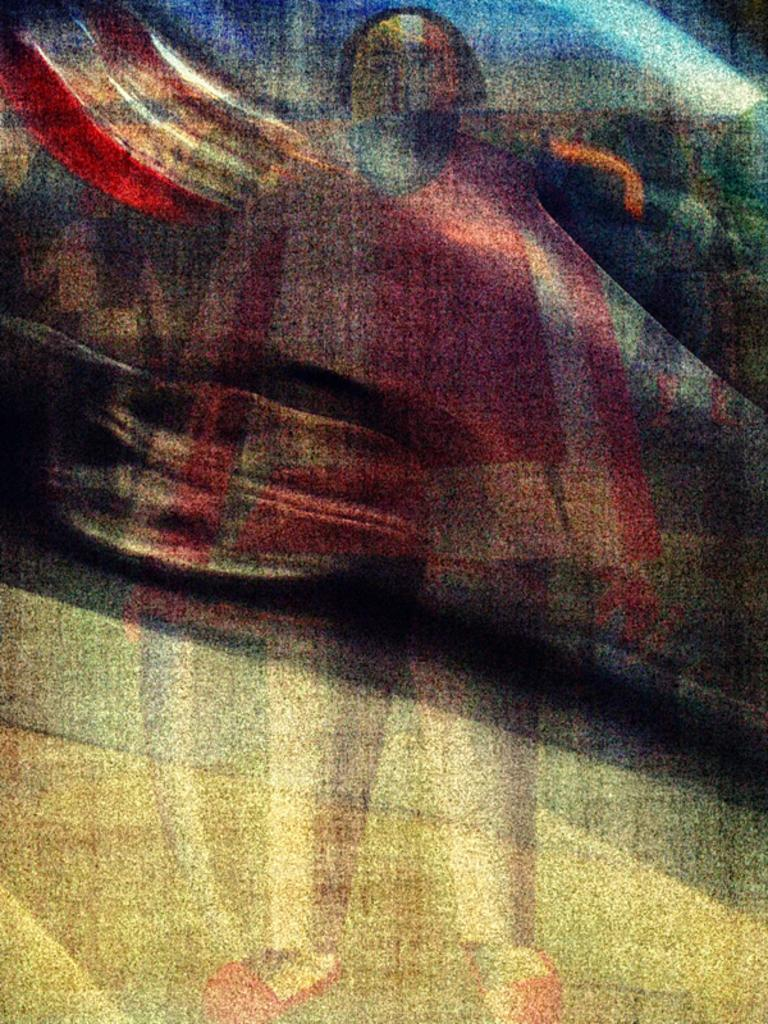What type of artwork is shown in the image? The image appears to be a painting. What is the main subject of the painting? There is a depiction of a person in the painting. Are there any other objects or elements in the painting? Yes, there is a depiction of a car in the painting. How many houses can be seen in the painting? There are no houses depicted in the painting; it features a person and a car. What color is the tongue of the person in the painting? There is no tongue visible in the painting, as the person is not depicted with their mouth open. 